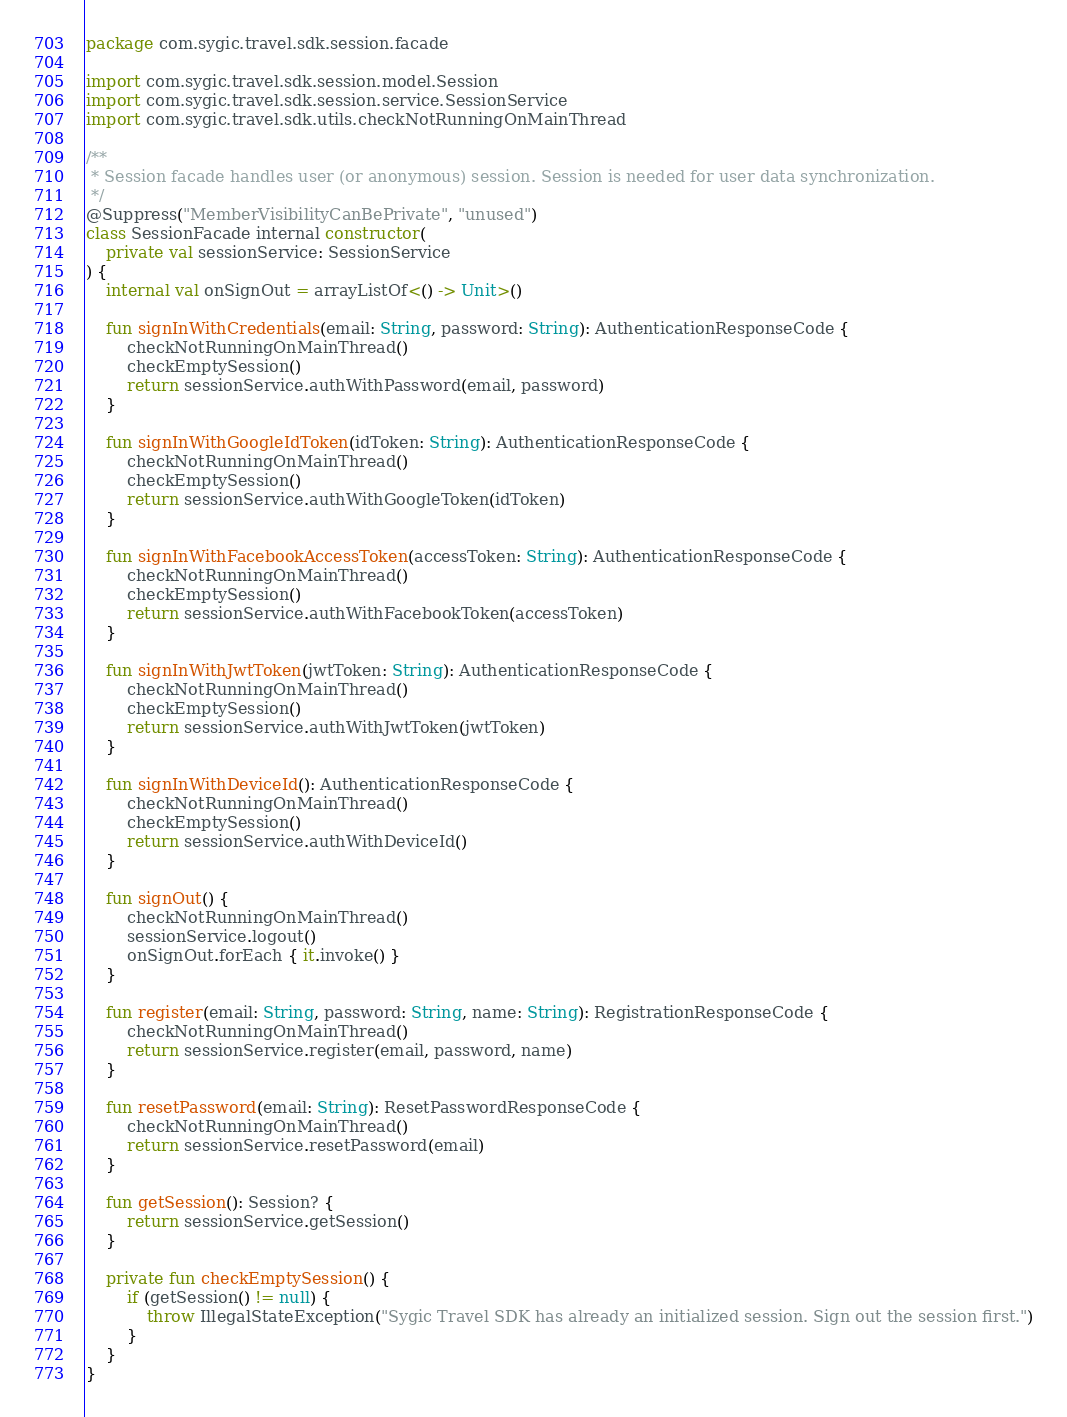<code> <loc_0><loc_0><loc_500><loc_500><_Kotlin_>package com.sygic.travel.sdk.session.facade

import com.sygic.travel.sdk.session.model.Session
import com.sygic.travel.sdk.session.service.SessionService
import com.sygic.travel.sdk.utils.checkNotRunningOnMainThread

/**
 * Session facade handles user (or anonymous) session. Session is needed for user data synchronization.
 */
@Suppress("MemberVisibilityCanBePrivate", "unused")
class SessionFacade internal constructor(
	private val sessionService: SessionService
) {
	internal val onSignOut = arrayListOf<() -> Unit>()

	fun signInWithCredentials(email: String, password: String): AuthenticationResponseCode {
		checkNotRunningOnMainThread()
		checkEmptySession()
		return sessionService.authWithPassword(email, password)
	}

	fun signInWithGoogleIdToken(idToken: String): AuthenticationResponseCode {
		checkNotRunningOnMainThread()
		checkEmptySession()
		return sessionService.authWithGoogleToken(idToken)
	}

	fun signInWithFacebookAccessToken(accessToken: String): AuthenticationResponseCode {
		checkNotRunningOnMainThread()
		checkEmptySession()
		return sessionService.authWithFacebookToken(accessToken)
	}

	fun signInWithJwtToken(jwtToken: String): AuthenticationResponseCode {
		checkNotRunningOnMainThread()
		checkEmptySession()
		return sessionService.authWithJwtToken(jwtToken)
	}

	fun signInWithDeviceId(): AuthenticationResponseCode {
		checkNotRunningOnMainThread()
		checkEmptySession()
		return sessionService.authWithDeviceId()
	}

	fun signOut() {
		checkNotRunningOnMainThread()
		sessionService.logout()
		onSignOut.forEach { it.invoke() }
	}

	fun register(email: String, password: String, name: String): RegistrationResponseCode {
		checkNotRunningOnMainThread()
		return sessionService.register(email, password, name)
	}

	fun resetPassword(email: String): ResetPasswordResponseCode {
		checkNotRunningOnMainThread()
		return sessionService.resetPassword(email)
	}

	fun getSession(): Session? {
		return sessionService.getSession()
	}

	private fun checkEmptySession() {
		if (getSession() != null) {
			throw IllegalStateException("Sygic Travel SDK has already an initialized session. Sign out the session first.")
		}
	}
}
</code> 